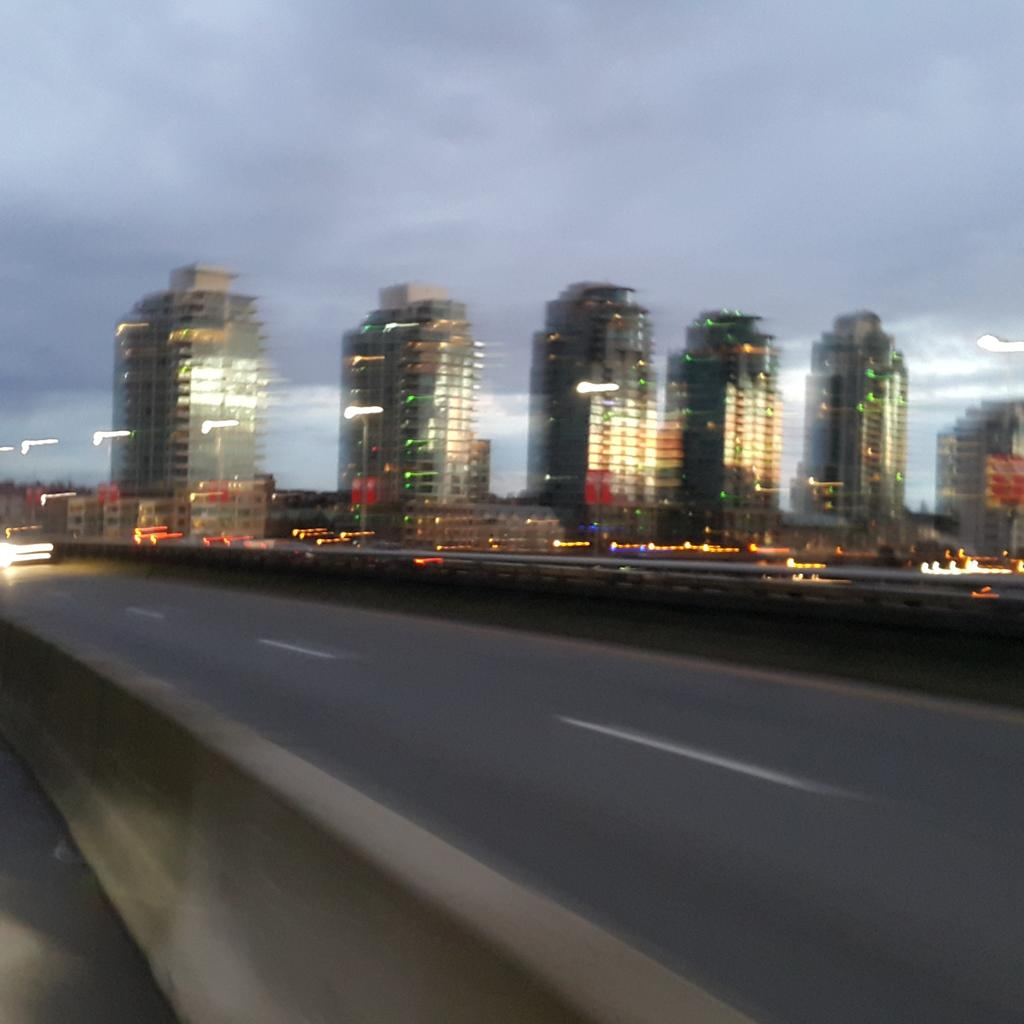What is the main feature of the image? There is a road in the image. What can be seen in the distance behind the road? There are buildings in the background of the image. How would you describe the weather in the image? The sky is cloudy in the image. Where is the paper market located in the image? There is no paper market present in the image. What time is displayed on the clock in the image? There is no clock present in the image. 